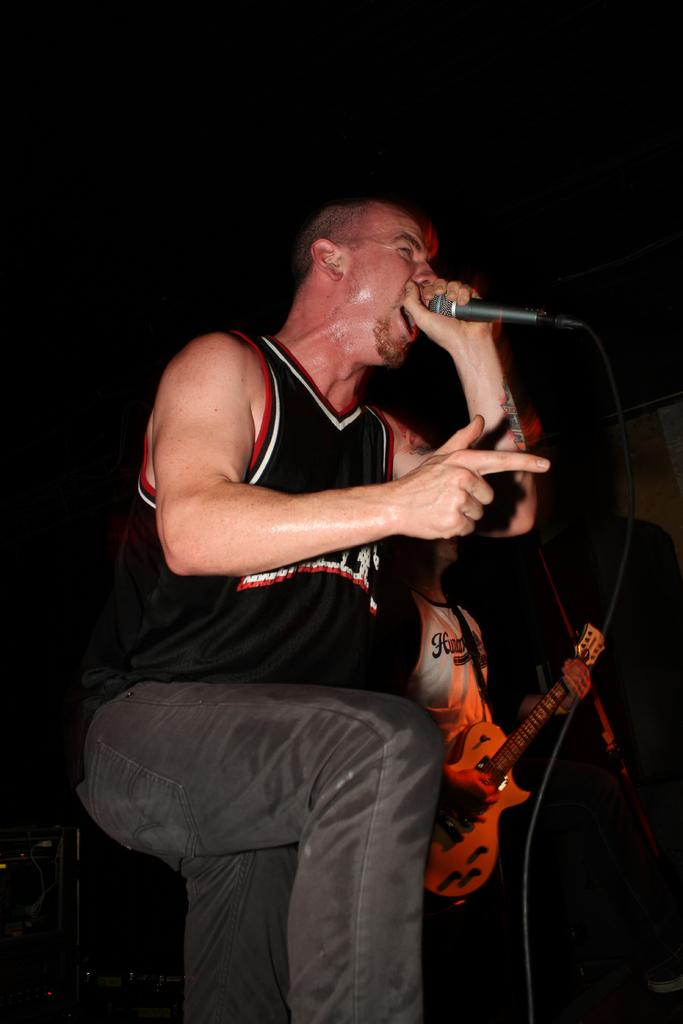How many people are in the image? There are two people in the image. What are the two people doing in the image? One person is singing into a microphone, and the other person is playing a guitar. What type of headphones is the person wearing while playing the guitar in the image? There is no mention of headphones in the image; the person is playing a guitar and not wearing any headphones. 